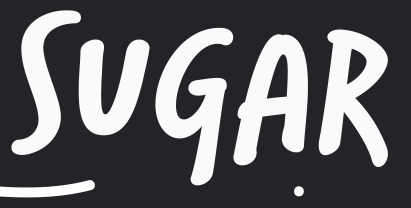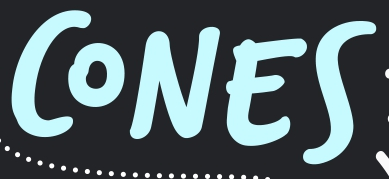Identify the words shown in these images in order, separated by a semicolon. SUGAR; CONES 